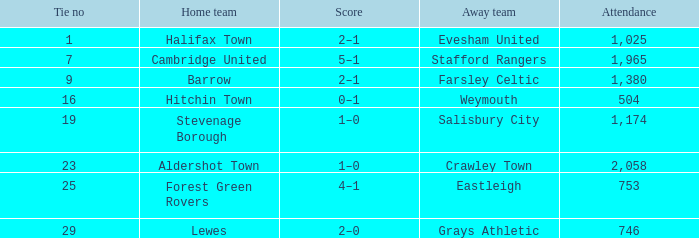What was the attendance for tie number 19? 1174.0. 